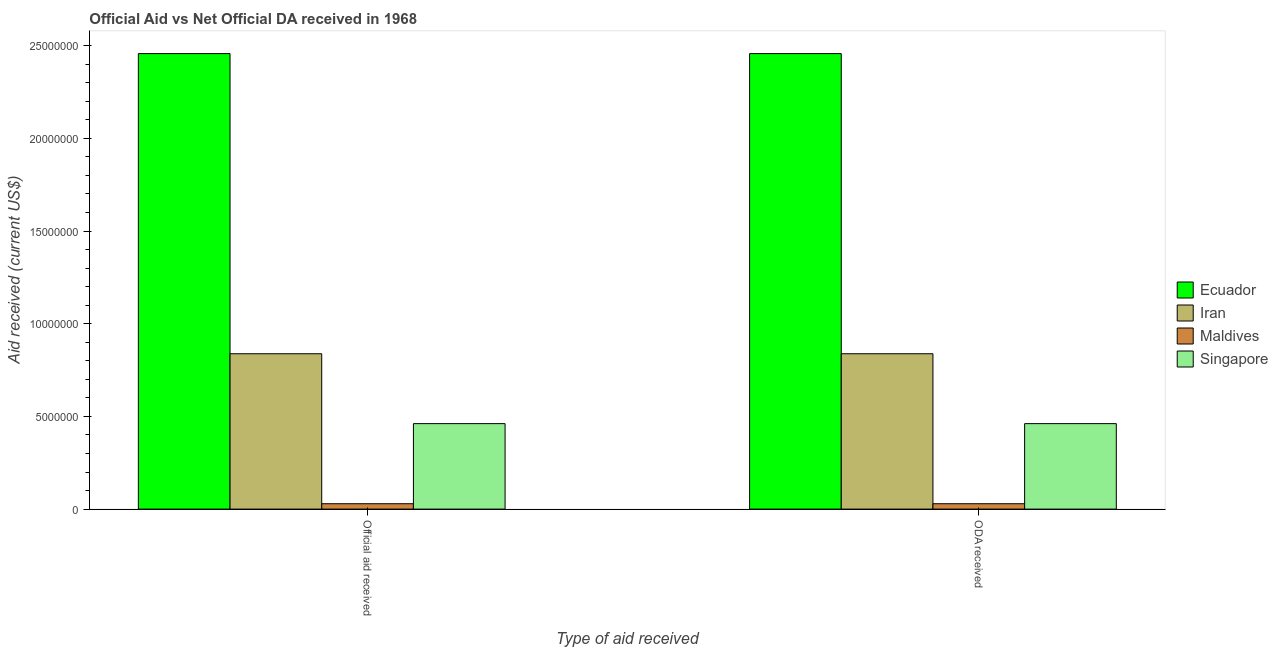What is the label of the 2nd group of bars from the left?
Your response must be concise. ODA received. What is the oda received in Ecuador?
Provide a short and direct response. 2.46e+07. Across all countries, what is the maximum oda received?
Give a very brief answer. 2.46e+07. Across all countries, what is the minimum oda received?
Keep it short and to the point. 2.90e+05. In which country was the oda received maximum?
Offer a terse response. Ecuador. In which country was the official aid received minimum?
Ensure brevity in your answer.  Maldives. What is the total official aid received in the graph?
Your answer should be very brief. 3.78e+07. What is the difference between the official aid received in Ecuador and that in Maldives?
Give a very brief answer. 2.43e+07. What is the difference between the official aid received in Singapore and the oda received in Ecuador?
Your response must be concise. -2.00e+07. What is the average official aid received per country?
Keep it short and to the point. 9.46e+06. What is the difference between the oda received and official aid received in Iran?
Offer a terse response. 0. What is the ratio of the official aid received in Ecuador to that in Singapore?
Your answer should be compact. 5.33. Is the official aid received in Ecuador less than that in Singapore?
Offer a terse response. No. What does the 3rd bar from the left in ODA received represents?
Make the answer very short. Maldives. What does the 3rd bar from the right in Official aid received represents?
Your answer should be compact. Iran. How many bars are there?
Your response must be concise. 8. How many countries are there in the graph?
Make the answer very short. 4. What is the difference between two consecutive major ticks on the Y-axis?
Make the answer very short. 5.00e+06. Where does the legend appear in the graph?
Offer a terse response. Center right. How are the legend labels stacked?
Offer a very short reply. Vertical. What is the title of the graph?
Provide a short and direct response. Official Aid vs Net Official DA received in 1968 . What is the label or title of the X-axis?
Give a very brief answer. Type of aid received. What is the label or title of the Y-axis?
Provide a succinct answer. Aid received (current US$). What is the Aid received (current US$) in Ecuador in Official aid received?
Offer a terse response. 2.46e+07. What is the Aid received (current US$) of Iran in Official aid received?
Your answer should be very brief. 8.38e+06. What is the Aid received (current US$) of Singapore in Official aid received?
Provide a succinct answer. 4.61e+06. What is the Aid received (current US$) in Ecuador in ODA received?
Make the answer very short. 2.46e+07. What is the Aid received (current US$) in Iran in ODA received?
Your answer should be very brief. 8.38e+06. What is the Aid received (current US$) of Maldives in ODA received?
Your answer should be compact. 2.90e+05. What is the Aid received (current US$) in Singapore in ODA received?
Offer a terse response. 4.61e+06. Across all Type of aid received, what is the maximum Aid received (current US$) of Ecuador?
Offer a terse response. 2.46e+07. Across all Type of aid received, what is the maximum Aid received (current US$) in Iran?
Give a very brief answer. 8.38e+06. Across all Type of aid received, what is the maximum Aid received (current US$) in Maldives?
Your response must be concise. 2.90e+05. Across all Type of aid received, what is the maximum Aid received (current US$) in Singapore?
Your answer should be very brief. 4.61e+06. Across all Type of aid received, what is the minimum Aid received (current US$) of Ecuador?
Give a very brief answer. 2.46e+07. Across all Type of aid received, what is the minimum Aid received (current US$) in Iran?
Your answer should be very brief. 8.38e+06. Across all Type of aid received, what is the minimum Aid received (current US$) of Maldives?
Provide a succinct answer. 2.90e+05. Across all Type of aid received, what is the minimum Aid received (current US$) in Singapore?
Give a very brief answer. 4.61e+06. What is the total Aid received (current US$) in Ecuador in the graph?
Provide a succinct answer. 4.91e+07. What is the total Aid received (current US$) in Iran in the graph?
Make the answer very short. 1.68e+07. What is the total Aid received (current US$) of Maldives in the graph?
Offer a very short reply. 5.80e+05. What is the total Aid received (current US$) of Singapore in the graph?
Your answer should be compact. 9.22e+06. What is the difference between the Aid received (current US$) in Ecuador in Official aid received and that in ODA received?
Your response must be concise. 0. What is the difference between the Aid received (current US$) of Iran in Official aid received and that in ODA received?
Provide a short and direct response. 0. What is the difference between the Aid received (current US$) in Maldives in Official aid received and that in ODA received?
Provide a short and direct response. 0. What is the difference between the Aid received (current US$) of Singapore in Official aid received and that in ODA received?
Give a very brief answer. 0. What is the difference between the Aid received (current US$) in Ecuador in Official aid received and the Aid received (current US$) in Iran in ODA received?
Offer a very short reply. 1.62e+07. What is the difference between the Aid received (current US$) in Ecuador in Official aid received and the Aid received (current US$) in Maldives in ODA received?
Provide a succinct answer. 2.43e+07. What is the difference between the Aid received (current US$) in Ecuador in Official aid received and the Aid received (current US$) in Singapore in ODA received?
Provide a succinct answer. 2.00e+07. What is the difference between the Aid received (current US$) of Iran in Official aid received and the Aid received (current US$) of Maldives in ODA received?
Provide a short and direct response. 8.09e+06. What is the difference between the Aid received (current US$) in Iran in Official aid received and the Aid received (current US$) in Singapore in ODA received?
Your answer should be very brief. 3.77e+06. What is the difference between the Aid received (current US$) of Maldives in Official aid received and the Aid received (current US$) of Singapore in ODA received?
Your answer should be compact. -4.32e+06. What is the average Aid received (current US$) of Ecuador per Type of aid received?
Provide a succinct answer. 2.46e+07. What is the average Aid received (current US$) of Iran per Type of aid received?
Offer a very short reply. 8.38e+06. What is the average Aid received (current US$) in Maldives per Type of aid received?
Your answer should be compact. 2.90e+05. What is the average Aid received (current US$) of Singapore per Type of aid received?
Provide a succinct answer. 4.61e+06. What is the difference between the Aid received (current US$) in Ecuador and Aid received (current US$) in Iran in Official aid received?
Offer a very short reply. 1.62e+07. What is the difference between the Aid received (current US$) of Ecuador and Aid received (current US$) of Maldives in Official aid received?
Keep it short and to the point. 2.43e+07. What is the difference between the Aid received (current US$) in Ecuador and Aid received (current US$) in Singapore in Official aid received?
Give a very brief answer. 2.00e+07. What is the difference between the Aid received (current US$) in Iran and Aid received (current US$) in Maldives in Official aid received?
Your response must be concise. 8.09e+06. What is the difference between the Aid received (current US$) of Iran and Aid received (current US$) of Singapore in Official aid received?
Your answer should be very brief. 3.77e+06. What is the difference between the Aid received (current US$) of Maldives and Aid received (current US$) of Singapore in Official aid received?
Ensure brevity in your answer.  -4.32e+06. What is the difference between the Aid received (current US$) of Ecuador and Aid received (current US$) of Iran in ODA received?
Give a very brief answer. 1.62e+07. What is the difference between the Aid received (current US$) of Ecuador and Aid received (current US$) of Maldives in ODA received?
Offer a terse response. 2.43e+07. What is the difference between the Aid received (current US$) in Ecuador and Aid received (current US$) in Singapore in ODA received?
Give a very brief answer. 2.00e+07. What is the difference between the Aid received (current US$) of Iran and Aid received (current US$) of Maldives in ODA received?
Ensure brevity in your answer.  8.09e+06. What is the difference between the Aid received (current US$) in Iran and Aid received (current US$) in Singapore in ODA received?
Offer a very short reply. 3.77e+06. What is the difference between the Aid received (current US$) of Maldives and Aid received (current US$) of Singapore in ODA received?
Your response must be concise. -4.32e+06. What is the ratio of the Aid received (current US$) in Ecuador in Official aid received to that in ODA received?
Make the answer very short. 1. What is the difference between the highest and the second highest Aid received (current US$) of Iran?
Your response must be concise. 0. What is the difference between the highest and the lowest Aid received (current US$) of Maldives?
Your response must be concise. 0. What is the difference between the highest and the lowest Aid received (current US$) in Singapore?
Your answer should be very brief. 0. 